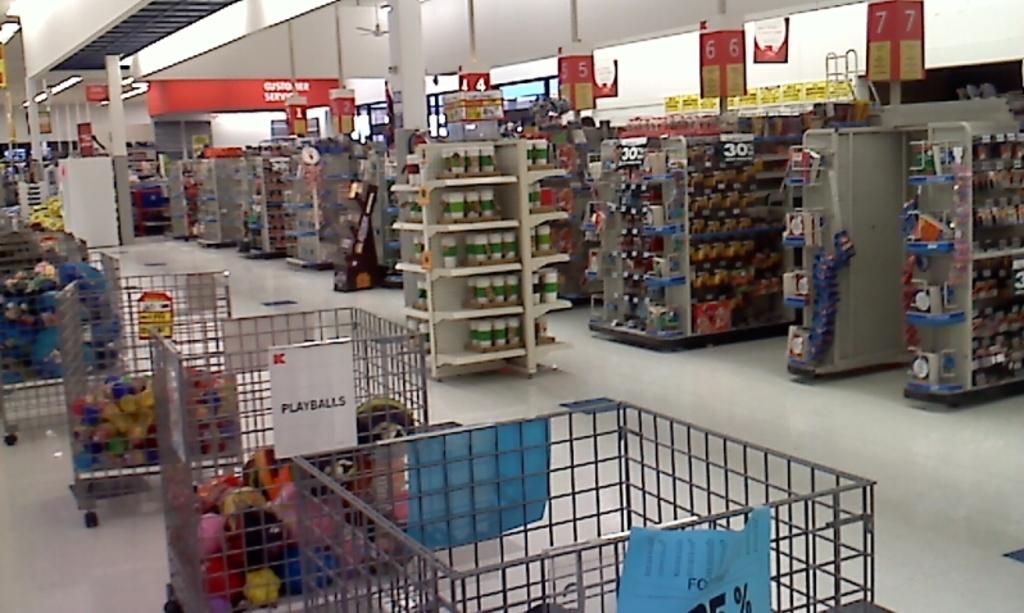<image>
Summarize the visual content of the image. Large carts of playballs with numbers 1 to 7 in the background 